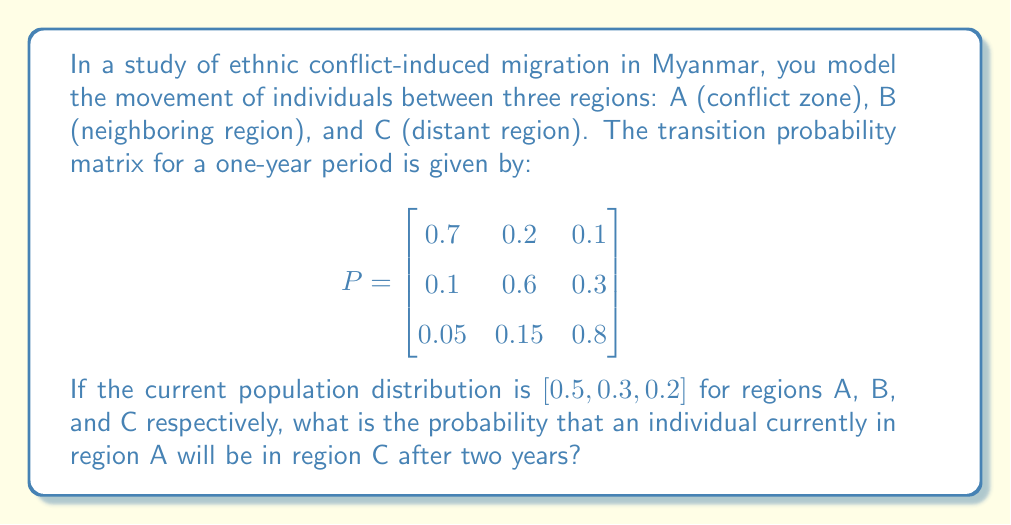Can you answer this question? To solve this problem, we need to use the properties of Markov chains and matrix multiplication. Let's approach this step-by-step:

1) First, we need to calculate the two-step transition probability matrix. This is done by multiplying the given transition matrix by itself:

   $$P^2 = P \times P = \begin{bmatrix}
   0.7 & 0.2 & 0.1 \\
   0.1 & 0.6 & 0.3 \\
   0.05 & 0.15 & 0.8
   \end{bmatrix} \times \begin{bmatrix}
   0.7 & 0.2 & 0.1 \\
   0.1 & 0.6 & 0.3 \\
   0.05 & 0.15 & 0.8
   \end{bmatrix}$$

2) Performing the matrix multiplication:

   $$P^2 = \begin{bmatrix}
   0.51 & 0.27 & 0.22 \\
   0.145 & 0.435 & 0.42 \\
   0.0875 & 0.2175 & 0.695
   \end{bmatrix}$$

3) The probability we're looking for is the element in the first row (region A) and third column (region C) of this new matrix.

4) Therefore, the probability that an individual currently in region A will be in region C after two years is 0.22 or 22%.

This result suggests that there's a significant probability of migration from the conflict zone to the distant region over a two-year period, which could be valuable information for your sociological research on the impact of ethnic conflicts on social structures in Myanmar.
Answer: 0.22 